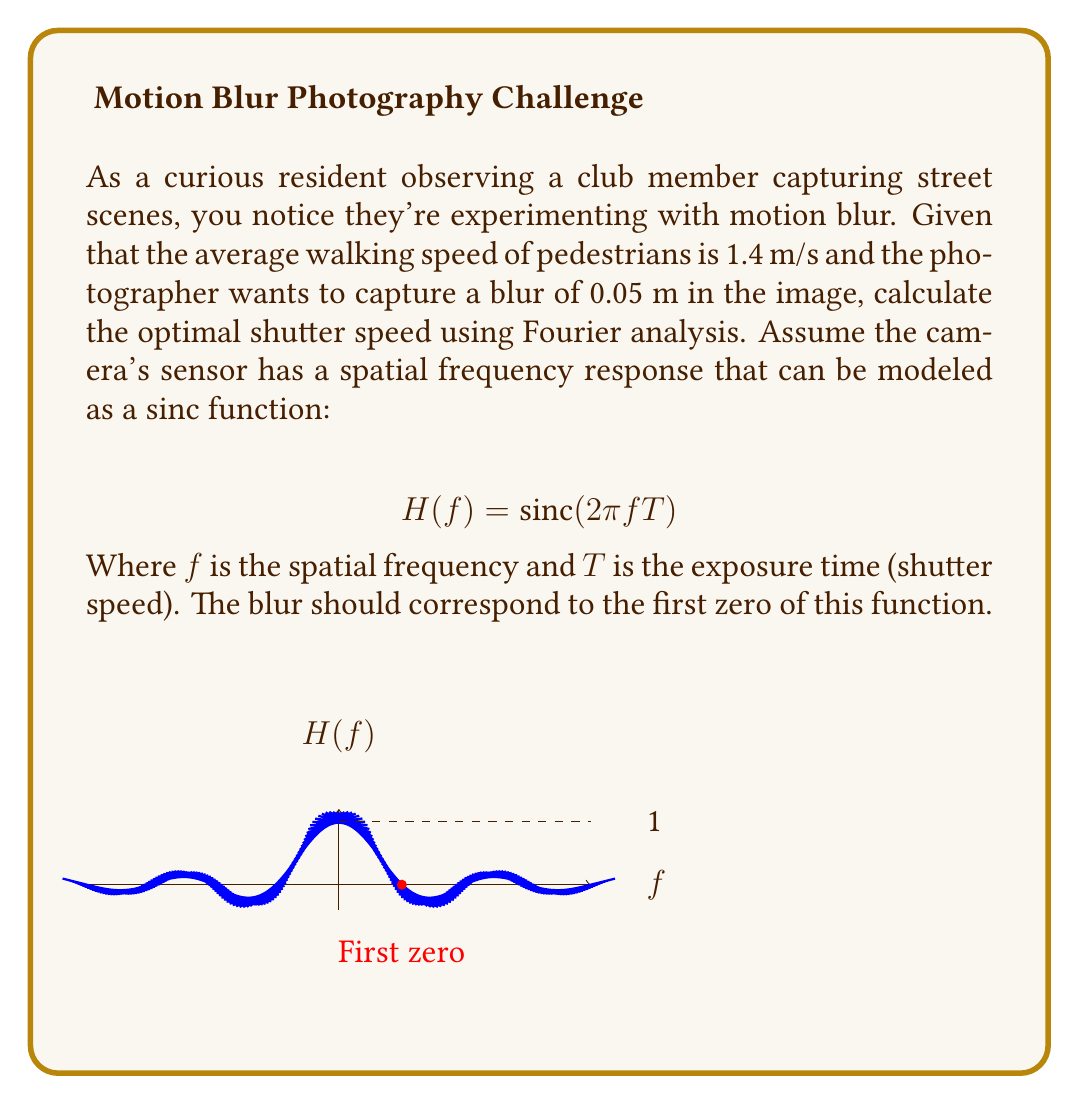Give your solution to this math problem. Let's approach this step-by-step:

1) The blur distance $d$ is related to the subject's velocity $v$ and the exposure time $T$:
   $$d = vT$$

2) We're given:
   $d = 0.05$ m (desired blur)
   $v = 1.4$ m/s (average walking speed)

3) The spatial frequency $f$ at which the first zero of the sinc function occurs is:
   $$f = \frac{1}{2T}$$

4) This frequency should correspond to the blur distance in the image. So:
   $$\frac{1}{d} = \frac{1}{2T}$$

5) Substituting the blur equation from step 1:
   $$\frac{1}{vT} = \frac{1}{2T}$$

6) Simplifying:
   $$\frac{2}{v} = T$$

7) Now we can substitute the known values:
   $$T = \frac{2}{1.4} \approx 1.43 \text{ seconds}$$

8) To verify, we can check if this produces the desired blur:
   $$d = vT = 1.4 \times 1.43 = 0.05 \text{ m}$$

   Which matches our initial requirement.
Answer: $T \approx 1.43$ seconds 